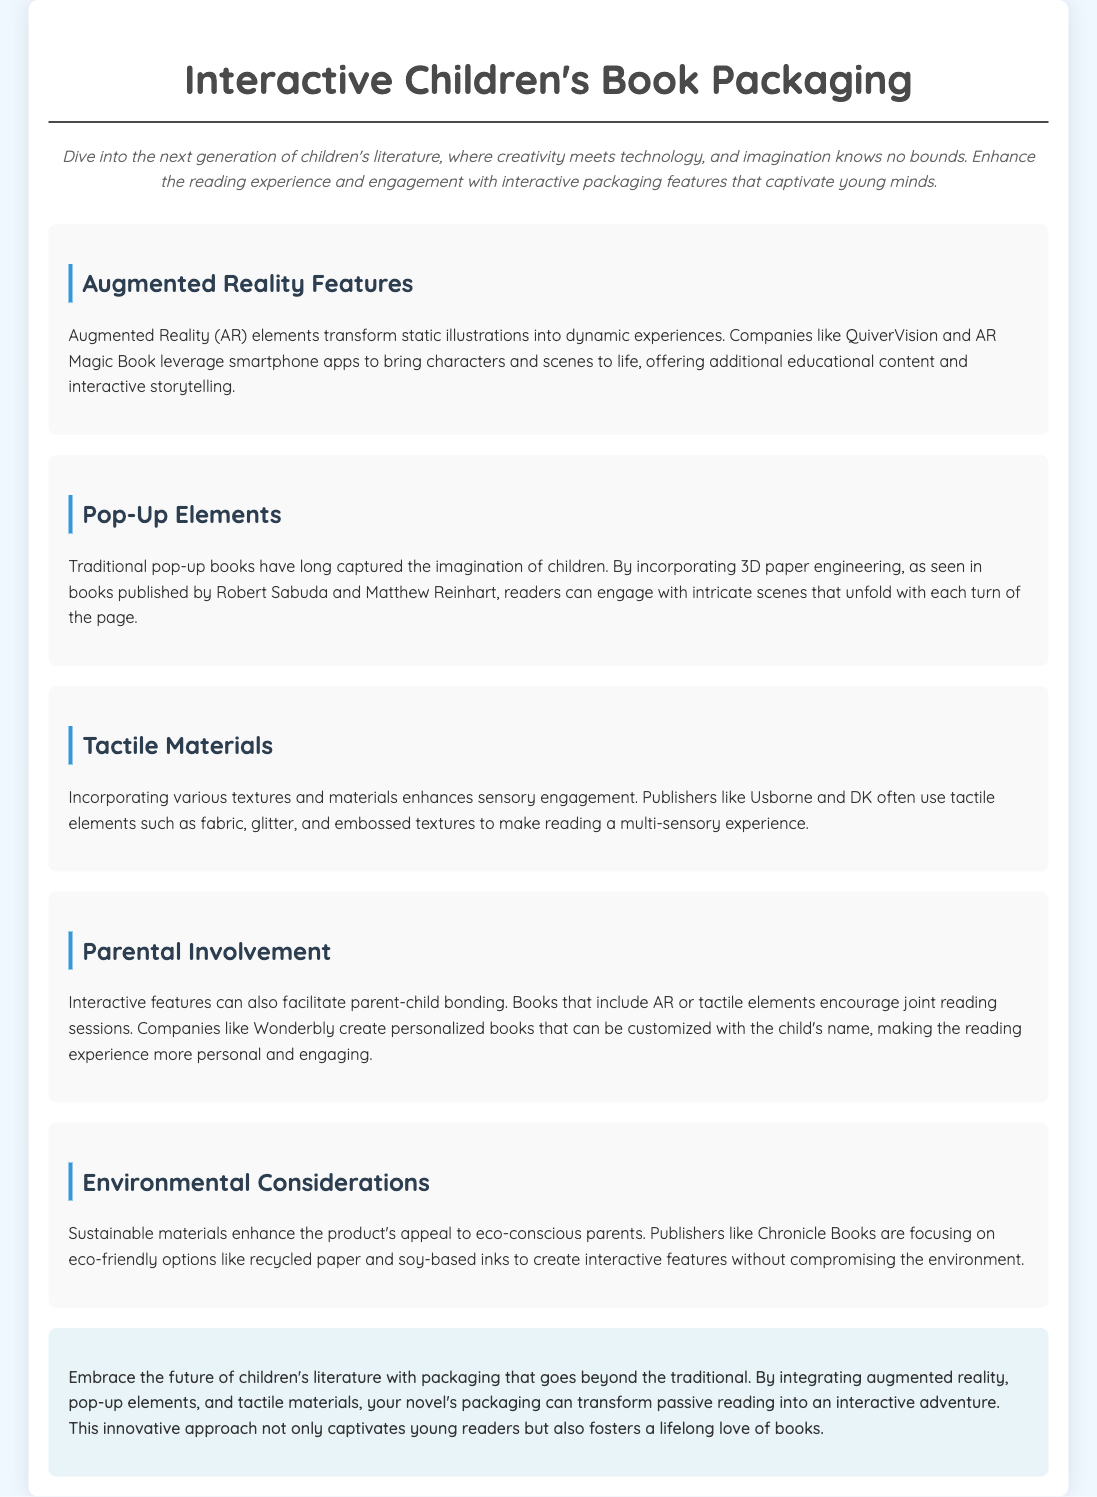What are augmented reality features? The document defines augmented reality features as elements that transform static illustrations into dynamic experiences.
Answer: Dynamic experiences Who are the publishers associated with pop-up elements? The document mentions Robert Sabuda and Matthew Reinhart as publishers associated with pop-up elements.
Answer: Robert Sabuda and Matthew Reinhart What type of materials enhance sensory engagement? The document states that incorporating various textures and materials enhances sensory engagement.
Answer: Textures and materials What is a benefit of interactive features mentioned in the document? The document highlights that interactive features can facilitate parent-child bonding during reading.
Answer: Parent-child bonding Which publishers focus on eco-friendly options? The document states that Chronicle Books focuses on eco-friendly options for interactive features.
Answer: Chronicle Books 